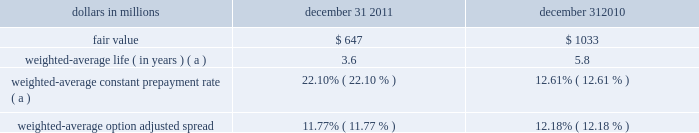Interest-earning assets including unearned income in the accretion of fair value adjustments on discounts recognized on acquired or purchased loans is recognized based on the constant effective yield of the financial instrument .
The timing and amount of revenue that we recognize in any period is dependent on estimates , judgments , assumptions , and interpretation of contractual terms .
Changes in these factors can have a significant impact on revenue recognized in any period due to changes in products , market conditions or industry norms .
Residential and commercial mortgage servicing rights we elect to measure our residential mortgage servicing rights ( msrs ) at fair value .
This election was made to be consistent with our risk management strategy to hedge changes in the fair value of these assets as described below .
The fair value of residential msrs is estimated by using a cash flow valuation model which calculates the present value of estimated future net servicing cash flows , taking into consideration actual and expected mortgage loan prepayment rates , discount rates , servicing costs , and other economic factors which are determined based on current market conditions .
Assumptions incorporated into the residential msrs valuation model reflect management 2019s best estimate of factors that a market participant would use in valuing the residential msrs .
Although sales of residential msrs do occur , residential msrs do not trade in an active market with readily observable prices so the precise terms and conditions of sales are not available .
As a benchmark for the reasonableness of its residential msrs fair value , pnc obtains opinions of value from independent parties ( 201cbrokers 201d ) .
These brokers provided a range ( +/- 10 bps ) based upon their own discounted cash flow calculations of our portfolio that reflected conditions in the secondary market , and any recently executed servicing transactions .
Pnc compares its internally-developed residential msrs value to the ranges of values received from the brokers .
If our residential msrs fair value falls outside of the brokers 2019 ranges , management will assess whether a valuation adjustment is warranted .
For 2011 and 2010 , pnc 2019s residential msrs value has not fallen outside of the brokers 2019 ranges .
We consider our residential msrs value to represent a reasonable estimate of fair value .
Commercial msrs are purchased or originated when loans are sold with servicing retained .
Commercial msrs do not trade in an active market with readily observable prices so the precise terms and conditions of sales are not available .
Commercial msrs are initially recorded at fair value and are subsequently accounted for at the lower of amortized cost or fair value .
Commercial msrs are periodically evaluated for impairment .
For purposes of impairment , the commercial mortgage servicing rights are stratified based on asset type , which characterizes the predominant risk of the underlying financial asset .
The fair value of commercial msrs is estimated by using an internal valuation model .
The model calculates the present value of estimated future net servicing cash flows considering estimates of servicing revenue and costs , discount rates and prepayment speeds .
Pnc employs risk management strategies designed to protect the value of msrs from changes in interest rates and related market factors .
Residential msrs values are economically hedged with securities and derivatives , including interest-rate swaps , options , and forward mortgage-backed and futures contracts .
As interest rates change , these financial instruments are expected to have changes in fair value negatively correlated to the change in fair value of the hedged residential msrs portfolio .
The hedge relationships are actively managed in response to changing market conditions over the life of the residential msrs assets .
Commercial msrs are economically hedged at a macro level or with specific derivatives to protect against a significant decline in interest rates .
Selecting appropriate financial instruments to economically hedge residential or commercial msrs requires significant management judgment to assess how mortgage rates and prepayment speeds could affect the future values of msrs .
Hedging results can frequently be less predictable in the short term , but over longer periods of time are expected to protect the economic value of the msrs .
The fair value of residential and commercial msrs and significant inputs to the valuation model as of december 31 , 2011 are shown in the tables below .
The expected and actual rates of mortgage loan prepayments are significant factors driving the fair value .
Management uses a third-party model to estimate future residential loan prepayments and internal proprietary models to estimate future commercial loan prepayments .
These models have been refined based on current market conditions .
Future interest rates are another important factor in the valuation of msrs .
Management utilizes market implied forward interest rates to estimate the future direction of mortgage and discount rates .
The forward rates utilized are derived from the current yield curve for u.s .
Dollar interest rate swaps and are consistent with pricing of capital markets instruments .
Changes in the shape and slope of the forward curve in future periods may result in volatility in the fair value estimate .
Residential mortgage servicing rights dollars in millions december 31 december 31 .
Weighted-average constant prepayment rate ( a ) 22.10% ( 22.10 % ) 12.61% ( 12.61 % ) weighted-average option adjusted spread 11.77% ( 11.77 % ) 12.18% ( 12.18 % ) ( a ) changes in weighted-average life and weighted-average constant prepayment rate reflect the cumulative impact of changes in rates , prepayment expectations and model changes .
The pnc financial services group , inc .
2013 form 10-k 65 .
In millions , what is the average msr fair value for 2010 and 2011? 
Computations: ((1033 + 647) / 2)
Answer: 840.0. Interest-earning assets including unearned income in the accretion of fair value adjustments on discounts recognized on acquired or purchased loans is recognized based on the constant effective yield of the financial instrument .
The timing and amount of revenue that we recognize in any period is dependent on estimates , judgments , assumptions , and interpretation of contractual terms .
Changes in these factors can have a significant impact on revenue recognized in any period due to changes in products , market conditions or industry norms .
Residential and commercial mortgage servicing rights we elect to measure our residential mortgage servicing rights ( msrs ) at fair value .
This election was made to be consistent with our risk management strategy to hedge changes in the fair value of these assets as described below .
The fair value of residential msrs is estimated by using a cash flow valuation model which calculates the present value of estimated future net servicing cash flows , taking into consideration actual and expected mortgage loan prepayment rates , discount rates , servicing costs , and other economic factors which are determined based on current market conditions .
Assumptions incorporated into the residential msrs valuation model reflect management 2019s best estimate of factors that a market participant would use in valuing the residential msrs .
Although sales of residential msrs do occur , residential msrs do not trade in an active market with readily observable prices so the precise terms and conditions of sales are not available .
As a benchmark for the reasonableness of its residential msrs fair value , pnc obtains opinions of value from independent parties ( 201cbrokers 201d ) .
These brokers provided a range ( +/- 10 bps ) based upon their own discounted cash flow calculations of our portfolio that reflected conditions in the secondary market , and any recently executed servicing transactions .
Pnc compares its internally-developed residential msrs value to the ranges of values received from the brokers .
If our residential msrs fair value falls outside of the brokers 2019 ranges , management will assess whether a valuation adjustment is warranted .
For 2011 and 2010 , pnc 2019s residential msrs value has not fallen outside of the brokers 2019 ranges .
We consider our residential msrs value to represent a reasonable estimate of fair value .
Commercial msrs are purchased or originated when loans are sold with servicing retained .
Commercial msrs do not trade in an active market with readily observable prices so the precise terms and conditions of sales are not available .
Commercial msrs are initially recorded at fair value and are subsequently accounted for at the lower of amortized cost or fair value .
Commercial msrs are periodically evaluated for impairment .
For purposes of impairment , the commercial mortgage servicing rights are stratified based on asset type , which characterizes the predominant risk of the underlying financial asset .
The fair value of commercial msrs is estimated by using an internal valuation model .
The model calculates the present value of estimated future net servicing cash flows considering estimates of servicing revenue and costs , discount rates and prepayment speeds .
Pnc employs risk management strategies designed to protect the value of msrs from changes in interest rates and related market factors .
Residential msrs values are economically hedged with securities and derivatives , including interest-rate swaps , options , and forward mortgage-backed and futures contracts .
As interest rates change , these financial instruments are expected to have changes in fair value negatively correlated to the change in fair value of the hedged residential msrs portfolio .
The hedge relationships are actively managed in response to changing market conditions over the life of the residential msrs assets .
Commercial msrs are economically hedged at a macro level or with specific derivatives to protect against a significant decline in interest rates .
Selecting appropriate financial instruments to economically hedge residential or commercial msrs requires significant management judgment to assess how mortgage rates and prepayment speeds could affect the future values of msrs .
Hedging results can frequently be less predictable in the short term , but over longer periods of time are expected to protect the economic value of the msrs .
The fair value of residential and commercial msrs and significant inputs to the valuation model as of december 31 , 2011 are shown in the tables below .
The expected and actual rates of mortgage loan prepayments are significant factors driving the fair value .
Management uses a third-party model to estimate future residential loan prepayments and internal proprietary models to estimate future commercial loan prepayments .
These models have been refined based on current market conditions .
Future interest rates are another important factor in the valuation of msrs .
Management utilizes market implied forward interest rates to estimate the future direction of mortgage and discount rates .
The forward rates utilized are derived from the current yield curve for u.s .
Dollar interest rate swaps and are consistent with pricing of capital markets instruments .
Changes in the shape and slope of the forward curve in future periods may result in volatility in the fair value estimate .
Residential mortgage servicing rights dollars in millions december 31 december 31 .
Weighted-average constant prepayment rate ( a ) 22.10% ( 22.10 % ) 12.61% ( 12.61 % ) weighted-average option adjusted spread 11.77% ( 11.77 % ) 12.18% ( 12.18 % ) ( a ) changes in weighted-average life and weighted-average constant prepayment rate reflect the cumulative impact of changes in rates , prepayment expectations and model changes .
The pnc financial services group , inc .
2013 form 10-k 65 .
By what percentage did the fair value decrease from 2010 to 2011? 
Computations: (((1033 - 647) / 1033) * 100)
Answer: 37.36689. 